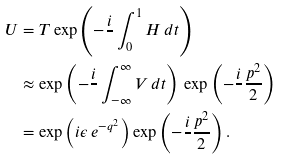<formula> <loc_0><loc_0><loc_500><loc_500>U & = T \exp \left ( - \frac { i } { } \int _ { 0 } ^ { 1 } H \, d t \right ) \\ & \approx \exp \left ( - \frac { i } { } \int _ { - \infty } ^ { \infty } V \, d t \right ) \, \exp \left ( - \frac { i } { } \frac { p ^ { 2 } } { 2 } \right ) \\ & = \exp \left ( i \epsilon \, e ^ { - q ^ { 2 } } \right ) \exp \left ( - \frac { i } { } \frac { p ^ { 2 } } { 2 } \right ) .</formula> 